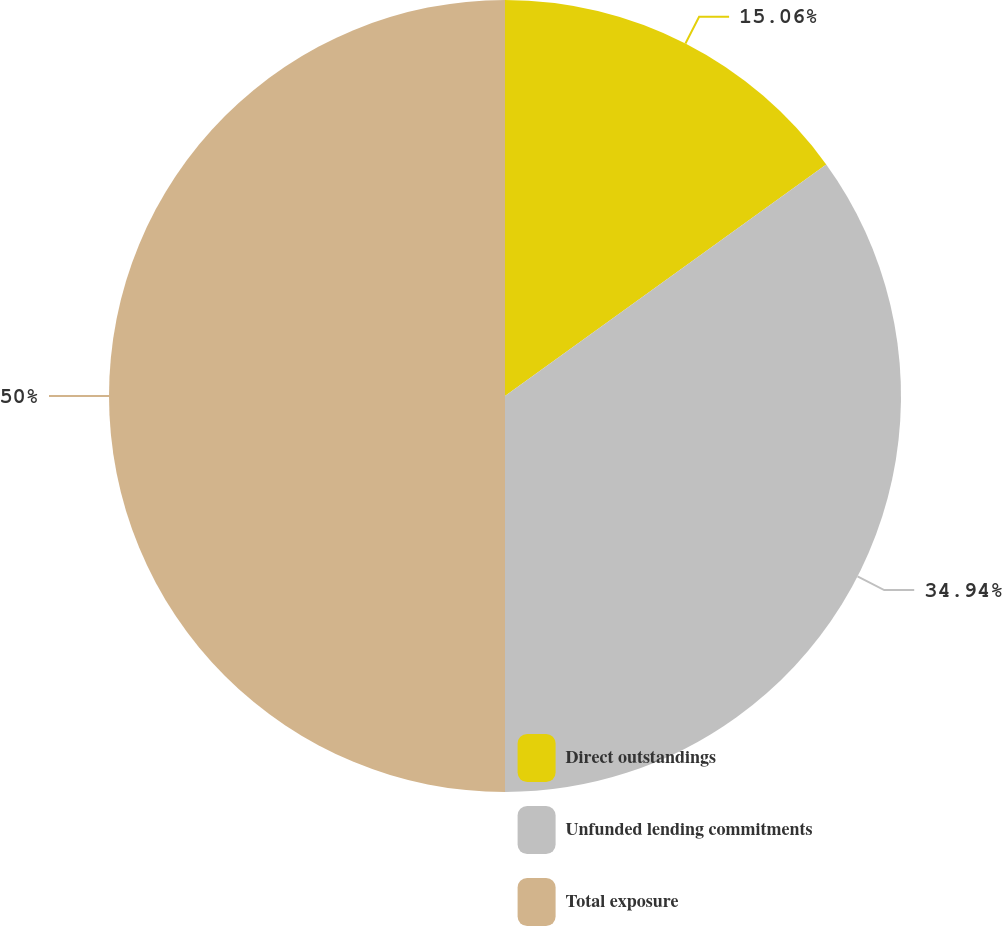<chart> <loc_0><loc_0><loc_500><loc_500><pie_chart><fcel>Direct outstandings<fcel>Unfunded lending commitments<fcel>Total exposure<nl><fcel>15.06%<fcel>34.94%<fcel>50.0%<nl></chart> 